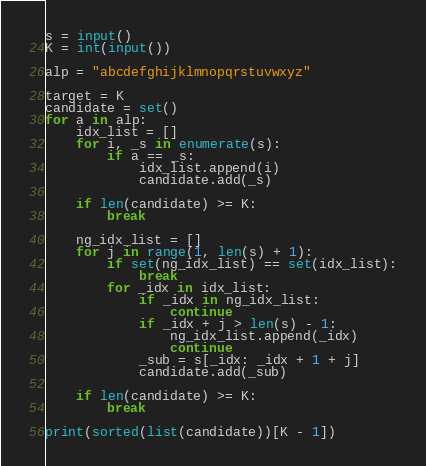<code> <loc_0><loc_0><loc_500><loc_500><_Python_>s = input()
K = int(input())

alp = "abcdefghijklmnopqrstuvwxyz"

target = K
candidate = set()
for a in alp:
    idx_list = []
    for i, _s in enumerate(s):
        if a == _s:
            idx_list.append(i)
            candidate.add(_s)

    if len(candidate) >= K:
        break

    ng_idx_list = []
    for j in range(1, len(s) + 1):
        if set(ng_idx_list) == set(idx_list):
            break
        for _idx in idx_list:
            if _idx in ng_idx_list:
                continue
            if _idx + j > len(s) - 1:
                ng_idx_list.append(_idx)
                continue
            _sub = s[_idx: _idx + 1 + j]
            candidate.add(_sub)

    if len(candidate) >= K:
        break

print(sorted(list(candidate))[K - 1])</code> 